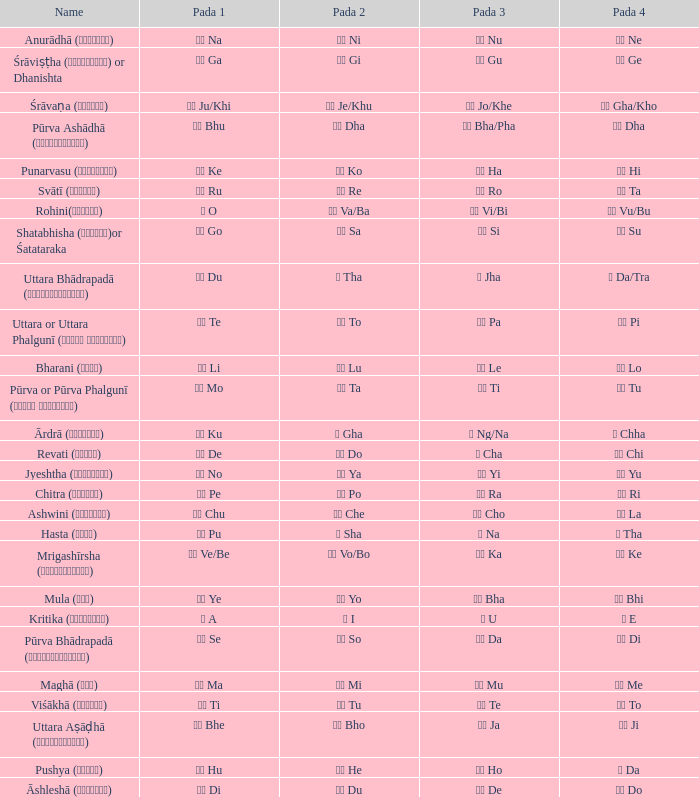Which Pada 3 has a Pada 1 of टे te? पा Pa. 